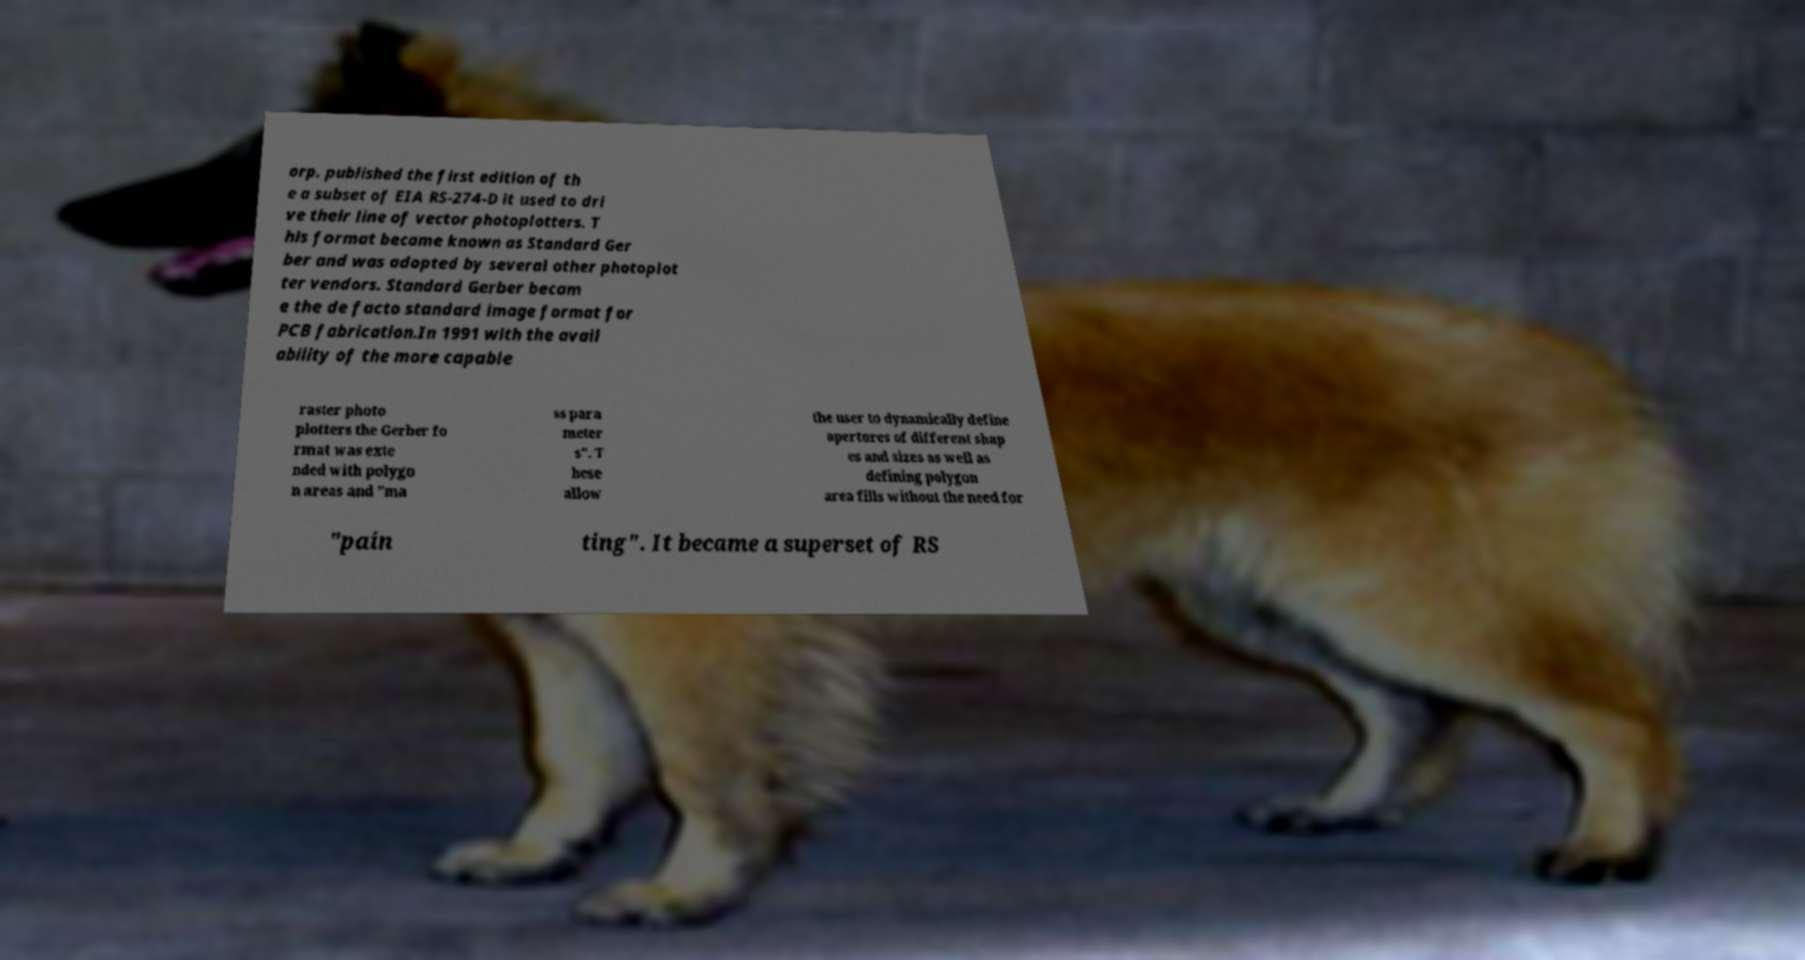For documentation purposes, I need the text within this image transcribed. Could you provide that? orp. published the first edition of th e a subset of EIA RS-274-D it used to dri ve their line of vector photoplotters. T his format became known as Standard Ger ber and was adopted by several other photoplot ter vendors. Standard Gerber becam e the de facto standard image format for PCB fabrication.In 1991 with the avail ability of the more capable raster photo plotters the Gerber fo rmat was exte nded with polygo n areas and "ma ss para meter s". T hese allow the user to dynamically define apertures of different shap es and sizes as well as defining polygon area fills without the need for "pain ting". It became a superset of RS 